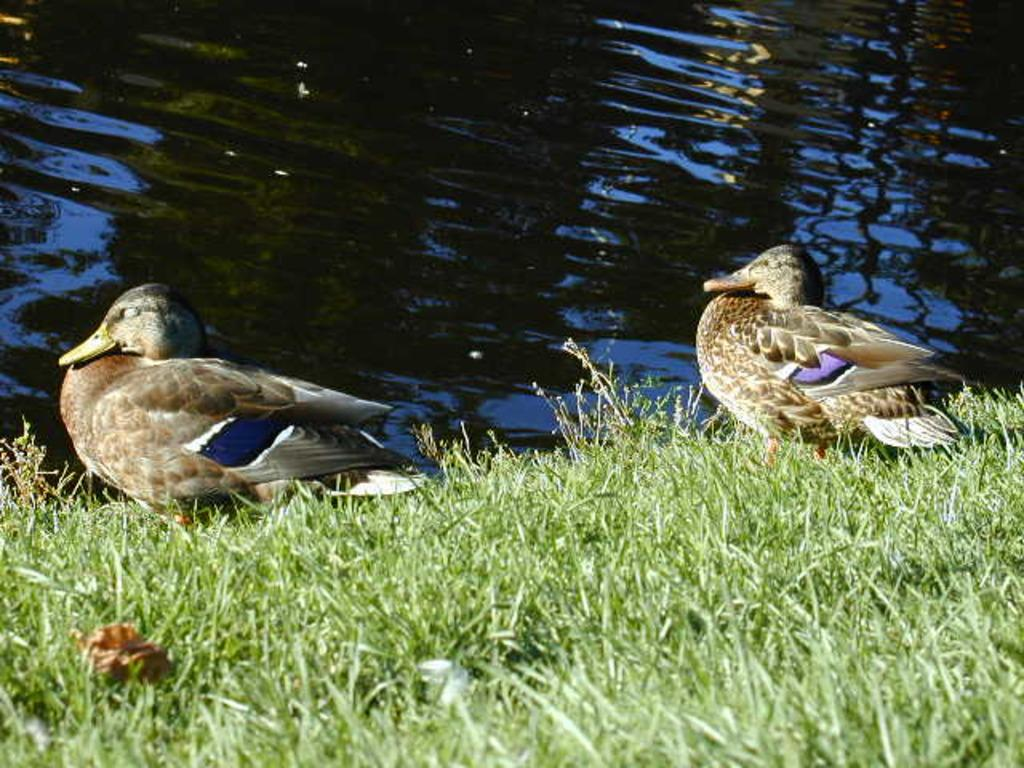How many birds are in the picture? There are two birds in the picture. What type of natural environment is depicted in the picture? The picture shows grass and water, which suggests a natural setting. Can you describe the birds' surroundings? The birds are in a grassy area with water visible in the background. How does the floor look in the picture? There is no floor visible in the picture; it shows a natural outdoor setting with grass and water. 